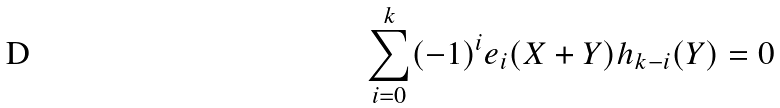Convert formula to latex. <formula><loc_0><loc_0><loc_500><loc_500>\sum _ { i = 0 } ^ { k } ( - 1 ) ^ { i } e _ { i } ( X + Y ) h _ { k - i } ( Y ) = 0</formula> 